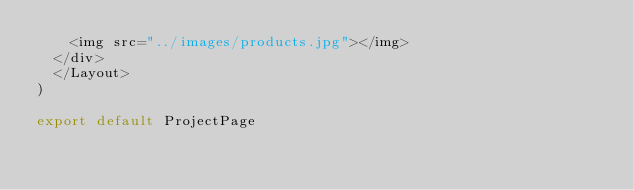Convert code to text. <code><loc_0><loc_0><loc_500><loc_500><_JavaScript_>    <img src="../images/products.jpg"></img>
  </div>
  </Layout>
)

export default ProjectPage
  </code> 